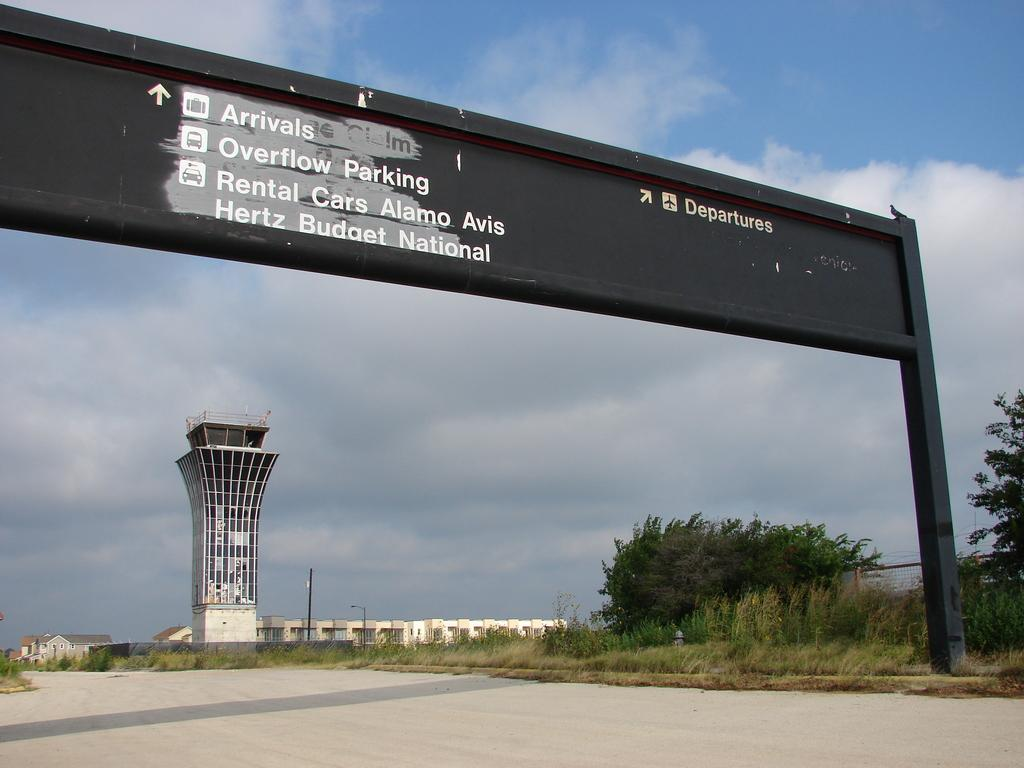<image>
Create a compact narrative representing the image presented. Departures at the airport are to the right. 